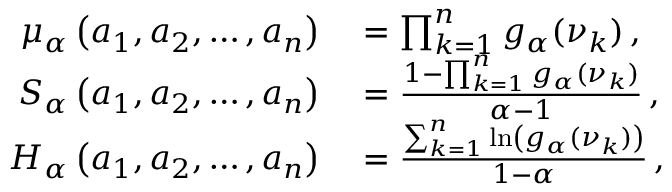Convert formula to latex. <formula><loc_0><loc_0><loc_500><loc_500>\begin{array} { r l } { \mu _ { \alpha } \left ( a _ { 1 } , a _ { 2 } , \dots , a _ { n } \right ) } & = \prod _ { k = 1 } ^ { n } g _ { \alpha } ( \nu _ { k } ) \, , } \\ { S _ { \alpha } \left ( a _ { 1 } , a _ { 2 } , \dots , a _ { n } \right ) } & = \frac { 1 - \prod _ { k = 1 } ^ { n } g _ { \alpha } ( \nu _ { k } ) } { \alpha - 1 } \, , } \\ { H _ { \alpha } \left ( a _ { 1 } , a _ { 2 } , \dots , a _ { n } \right ) } & = \frac { \sum _ { k = 1 } ^ { n } \ln \left ( g _ { \alpha } ( \nu _ { k } ) \right ) } { 1 - \alpha } \, , } \end{array}</formula> 